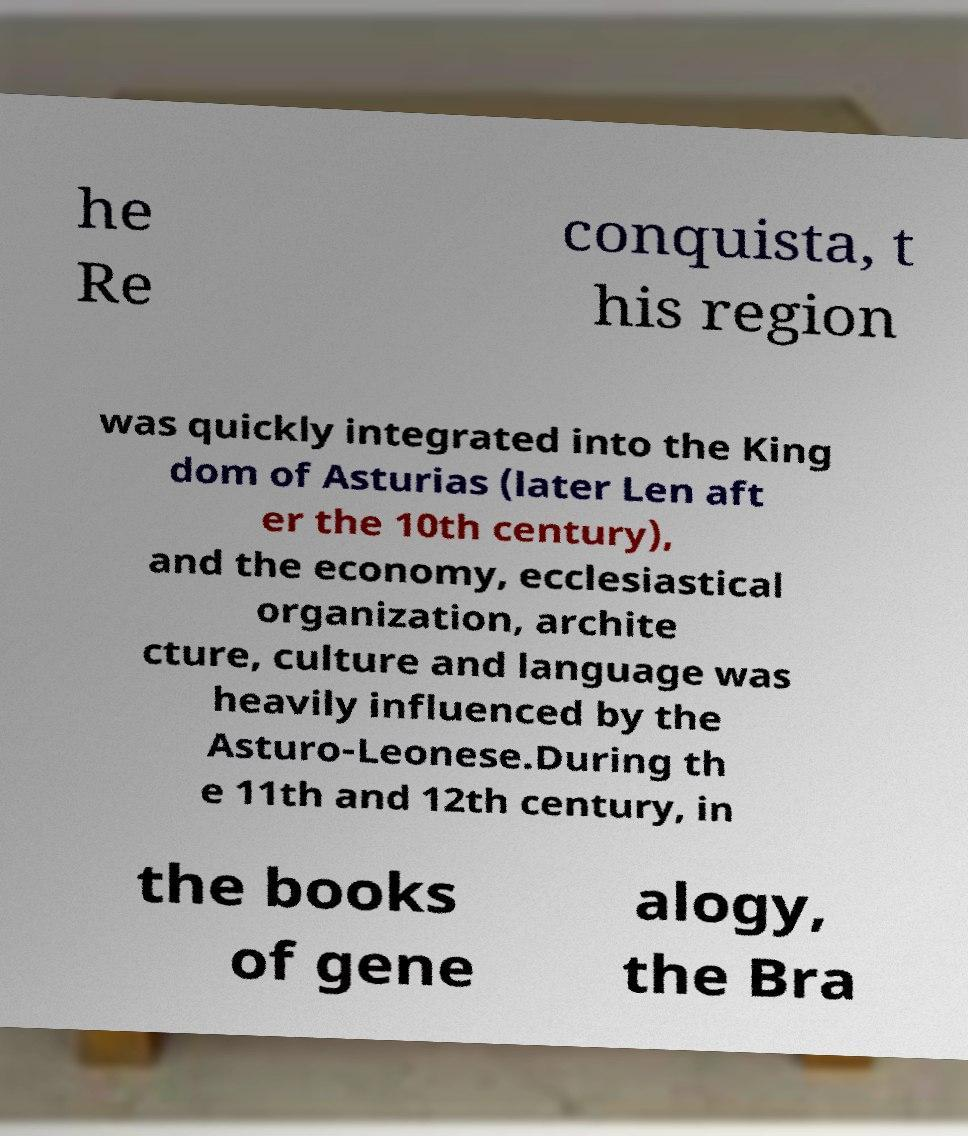There's text embedded in this image that I need extracted. Can you transcribe it verbatim? he Re conquista, t his region was quickly integrated into the King dom of Asturias (later Len aft er the 10th century), and the economy, ecclesiastical organization, archite cture, culture and language was heavily influenced by the Asturo-Leonese.During th e 11th and 12th century, in the books of gene alogy, the Bra 